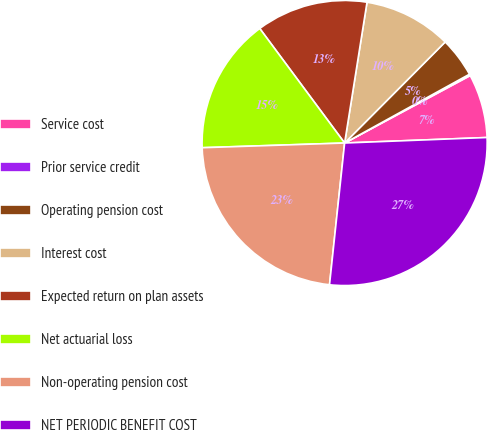Convert chart. <chart><loc_0><loc_0><loc_500><loc_500><pie_chart><fcel>Service cost<fcel>Prior service credit<fcel>Operating pension cost<fcel>Interest cost<fcel>Expected return on plan assets<fcel>Net actuarial loss<fcel>Non-operating pension cost<fcel>NET PERIODIC BENEFIT COST<nl><fcel>7.23%<fcel>0.17%<fcel>4.52%<fcel>9.95%<fcel>12.66%<fcel>15.37%<fcel>22.78%<fcel>27.3%<nl></chart> 